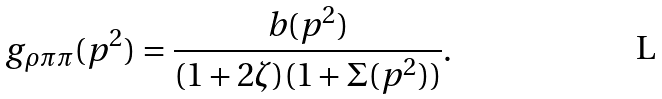Convert formula to latex. <formula><loc_0><loc_0><loc_500><loc_500>g _ { \rho \pi \pi } ( p ^ { 2 } ) = \frac { b ( p ^ { 2 } ) } { ( 1 + 2 \zeta ) ( 1 + \Sigma ( p ^ { 2 } ) ) } .</formula> 